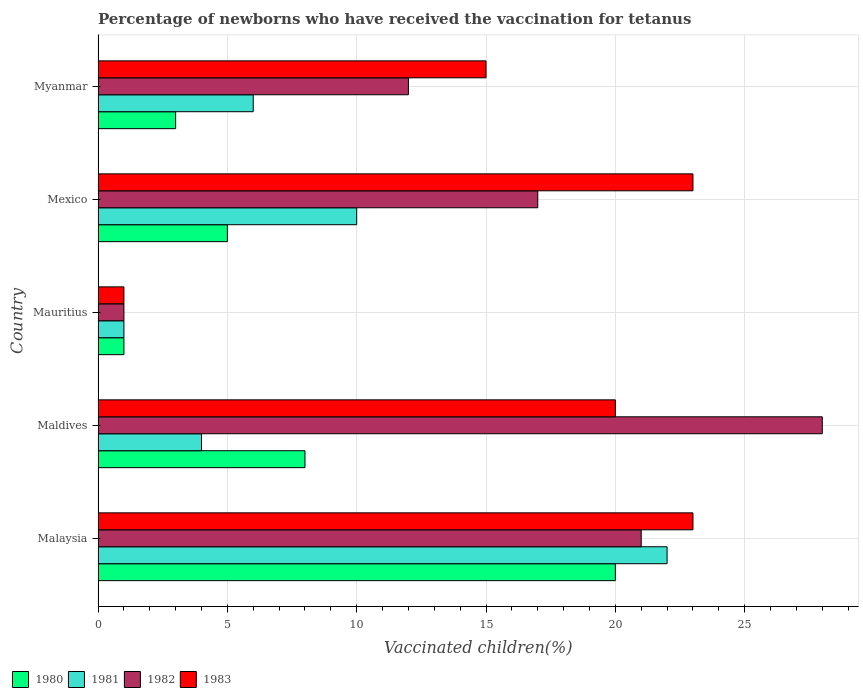How many different coloured bars are there?
Your answer should be very brief. 4. How many groups of bars are there?
Your answer should be compact. 5. Are the number of bars per tick equal to the number of legend labels?
Your response must be concise. Yes. Are the number of bars on each tick of the Y-axis equal?
Provide a short and direct response. Yes. What is the label of the 2nd group of bars from the top?
Provide a succinct answer. Mexico. In how many cases, is the number of bars for a given country not equal to the number of legend labels?
Give a very brief answer. 0. Across all countries, what is the minimum percentage of vaccinated children in 1982?
Your response must be concise. 1. In which country was the percentage of vaccinated children in 1983 maximum?
Make the answer very short. Malaysia. In which country was the percentage of vaccinated children in 1983 minimum?
Ensure brevity in your answer.  Mauritius. What is the total percentage of vaccinated children in 1983 in the graph?
Your response must be concise. 82. What is the difference between the percentage of vaccinated children in 1983 in Maldives and the percentage of vaccinated children in 1980 in Mauritius?
Your response must be concise. 19. What is the average percentage of vaccinated children in 1983 per country?
Offer a terse response. 16.4. In how many countries, is the percentage of vaccinated children in 1981 greater than 28 %?
Provide a short and direct response. 0. What is the ratio of the percentage of vaccinated children in 1983 in Maldives to that in Myanmar?
Keep it short and to the point. 1.33. Is the difference between the percentage of vaccinated children in 1980 in Maldives and Mauritius greater than the difference between the percentage of vaccinated children in 1983 in Maldives and Mauritius?
Ensure brevity in your answer.  No. In how many countries, is the percentage of vaccinated children in 1983 greater than the average percentage of vaccinated children in 1983 taken over all countries?
Your answer should be very brief. 3. Is it the case that in every country, the sum of the percentage of vaccinated children in 1983 and percentage of vaccinated children in 1981 is greater than the sum of percentage of vaccinated children in 1982 and percentage of vaccinated children in 1980?
Provide a short and direct response. No. What does the 4th bar from the top in Maldives represents?
Your answer should be very brief. 1980. Is it the case that in every country, the sum of the percentage of vaccinated children in 1981 and percentage of vaccinated children in 1982 is greater than the percentage of vaccinated children in 1980?
Your response must be concise. Yes. How many bars are there?
Provide a succinct answer. 20. Are all the bars in the graph horizontal?
Provide a short and direct response. Yes. How many countries are there in the graph?
Your answer should be very brief. 5. Are the values on the major ticks of X-axis written in scientific E-notation?
Your answer should be very brief. No. Does the graph contain grids?
Ensure brevity in your answer.  Yes. Where does the legend appear in the graph?
Offer a terse response. Bottom left. How many legend labels are there?
Offer a very short reply. 4. How are the legend labels stacked?
Keep it short and to the point. Horizontal. What is the title of the graph?
Your answer should be compact. Percentage of newborns who have received the vaccination for tetanus. What is the label or title of the X-axis?
Offer a very short reply. Vaccinated children(%). What is the label or title of the Y-axis?
Make the answer very short. Country. What is the Vaccinated children(%) of 1980 in Malaysia?
Offer a very short reply. 20. What is the Vaccinated children(%) in 1981 in Malaysia?
Provide a short and direct response. 22. What is the Vaccinated children(%) in 1982 in Malaysia?
Ensure brevity in your answer.  21. What is the Vaccinated children(%) in 1983 in Malaysia?
Make the answer very short. 23. What is the Vaccinated children(%) in 1981 in Maldives?
Provide a short and direct response. 4. What is the Vaccinated children(%) in 1982 in Maldives?
Offer a terse response. 28. What is the Vaccinated children(%) of 1983 in Maldives?
Give a very brief answer. 20. What is the Vaccinated children(%) of 1981 in Mauritius?
Keep it short and to the point. 1. What is the Vaccinated children(%) in 1982 in Mauritius?
Provide a succinct answer. 1. What is the Vaccinated children(%) in 1983 in Mauritius?
Offer a terse response. 1. What is the Vaccinated children(%) of 1982 in Mexico?
Keep it short and to the point. 17. What is the Vaccinated children(%) in 1983 in Mexico?
Your answer should be very brief. 23. What is the Vaccinated children(%) of 1980 in Myanmar?
Your response must be concise. 3. What is the Vaccinated children(%) of 1981 in Myanmar?
Make the answer very short. 6. What is the Vaccinated children(%) in 1983 in Myanmar?
Make the answer very short. 15. Across all countries, what is the maximum Vaccinated children(%) of 1980?
Provide a short and direct response. 20. Across all countries, what is the maximum Vaccinated children(%) in 1983?
Offer a very short reply. 23. Across all countries, what is the minimum Vaccinated children(%) in 1981?
Offer a terse response. 1. Across all countries, what is the minimum Vaccinated children(%) in 1982?
Provide a short and direct response. 1. What is the total Vaccinated children(%) in 1980 in the graph?
Give a very brief answer. 37. What is the total Vaccinated children(%) of 1982 in the graph?
Your response must be concise. 79. What is the difference between the Vaccinated children(%) of 1980 in Malaysia and that in Maldives?
Give a very brief answer. 12. What is the difference between the Vaccinated children(%) in 1981 in Malaysia and that in Maldives?
Offer a very short reply. 18. What is the difference between the Vaccinated children(%) of 1983 in Malaysia and that in Maldives?
Ensure brevity in your answer.  3. What is the difference between the Vaccinated children(%) in 1980 in Malaysia and that in Mauritius?
Offer a terse response. 19. What is the difference between the Vaccinated children(%) of 1981 in Malaysia and that in Mauritius?
Provide a short and direct response. 21. What is the difference between the Vaccinated children(%) in 1982 in Malaysia and that in Mauritius?
Offer a very short reply. 20. What is the difference between the Vaccinated children(%) in 1983 in Malaysia and that in Mauritius?
Ensure brevity in your answer.  22. What is the difference between the Vaccinated children(%) of 1980 in Malaysia and that in Mexico?
Provide a succinct answer. 15. What is the difference between the Vaccinated children(%) in 1981 in Malaysia and that in Mexico?
Ensure brevity in your answer.  12. What is the difference between the Vaccinated children(%) of 1982 in Malaysia and that in Myanmar?
Provide a short and direct response. 9. What is the difference between the Vaccinated children(%) of 1983 in Malaysia and that in Myanmar?
Offer a terse response. 8. What is the difference between the Vaccinated children(%) of 1981 in Maldives and that in Mauritius?
Provide a succinct answer. 3. What is the difference between the Vaccinated children(%) in 1982 in Maldives and that in Mauritius?
Your answer should be compact. 27. What is the difference between the Vaccinated children(%) of 1983 in Maldives and that in Mauritius?
Provide a succinct answer. 19. What is the difference between the Vaccinated children(%) of 1981 in Maldives and that in Mexico?
Keep it short and to the point. -6. What is the difference between the Vaccinated children(%) of 1980 in Maldives and that in Myanmar?
Your answer should be very brief. 5. What is the difference between the Vaccinated children(%) of 1983 in Maldives and that in Myanmar?
Make the answer very short. 5. What is the difference between the Vaccinated children(%) in 1980 in Mauritius and that in Mexico?
Ensure brevity in your answer.  -4. What is the difference between the Vaccinated children(%) of 1981 in Mauritius and that in Mexico?
Your answer should be compact. -9. What is the difference between the Vaccinated children(%) of 1982 in Mauritius and that in Mexico?
Your answer should be compact. -16. What is the difference between the Vaccinated children(%) of 1983 in Mauritius and that in Mexico?
Provide a succinct answer. -22. What is the difference between the Vaccinated children(%) of 1982 in Mauritius and that in Myanmar?
Ensure brevity in your answer.  -11. What is the difference between the Vaccinated children(%) in 1983 in Mauritius and that in Myanmar?
Offer a very short reply. -14. What is the difference between the Vaccinated children(%) of 1980 in Mexico and that in Myanmar?
Give a very brief answer. 2. What is the difference between the Vaccinated children(%) in 1980 in Malaysia and the Vaccinated children(%) in 1981 in Maldives?
Offer a terse response. 16. What is the difference between the Vaccinated children(%) of 1980 in Malaysia and the Vaccinated children(%) of 1982 in Maldives?
Keep it short and to the point. -8. What is the difference between the Vaccinated children(%) in 1981 in Malaysia and the Vaccinated children(%) in 1983 in Maldives?
Provide a short and direct response. 2. What is the difference between the Vaccinated children(%) of 1982 in Malaysia and the Vaccinated children(%) of 1983 in Maldives?
Provide a succinct answer. 1. What is the difference between the Vaccinated children(%) of 1980 in Malaysia and the Vaccinated children(%) of 1983 in Mauritius?
Offer a very short reply. 19. What is the difference between the Vaccinated children(%) of 1981 in Malaysia and the Vaccinated children(%) of 1982 in Mexico?
Offer a very short reply. 5. What is the difference between the Vaccinated children(%) of 1981 in Malaysia and the Vaccinated children(%) of 1983 in Mexico?
Make the answer very short. -1. What is the difference between the Vaccinated children(%) in 1980 in Malaysia and the Vaccinated children(%) in 1981 in Myanmar?
Keep it short and to the point. 14. What is the difference between the Vaccinated children(%) of 1981 in Malaysia and the Vaccinated children(%) of 1983 in Myanmar?
Offer a terse response. 7. What is the difference between the Vaccinated children(%) in 1982 in Malaysia and the Vaccinated children(%) in 1983 in Myanmar?
Your answer should be compact. 6. What is the difference between the Vaccinated children(%) in 1980 in Maldives and the Vaccinated children(%) in 1981 in Mauritius?
Your answer should be compact. 7. What is the difference between the Vaccinated children(%) in 1980 in Maldives and the Vaccinated children(%) in 1983 in Mauritius?
Ensure brevity in your answer.  7. What is the difference between the Vaccinated children(%) in 1981 in Maldives and the Vaccinated children(%) in 1983 in Mauritius?
Make the answer very short. 3. What is the difference between the Vaccinated children(%) of 1980 in Maldives and the Vaccinated children(%) of 1981 in Mexico?
Your answer should be compact. -2. What is the difference between the Vaccinated children(%) of 1980 in Maldives and the Vaccinated children(%) of 1982 in Mexico?
Provide a short and direct response. -9. What is the difference between the Vaccinated children(%) in 1980 in Maldives and the Vaccinated children(%) in 1983 in Mexico?
Ensure brevity in your answer.  -15. What is the difference between the Vaccinated children(%) in 1981 in Maldives and the Vaccinated children(%) in 1983 in Mexico?
Offer a very short reply. -19. What is the difference between the Vaccinated children(%) in 1980 in Maldives and the Vaccinated children(%) in 1982 in Myanmar?
Ensure brevity in your answer.  -4. What is the difference between the Vaccinated children(%) in 1980 in Maldives and the Vaccinated children(%) in 1983 in Myanmar?
Provide a succinct answer. -7. What is the difference between the Vaccinated children(%) of 1981 in Maldives and the Vaccinated children(%) of 1982 in Myanmar?
Provide a succinct answer. -8. What is the difference between the Vaccinated children(%) in 1982 in Maldives and the Vaccinated children(%) in 1983 in Myanmar?
Provide a succinct answer. 13. What is the difference between the Vaccinated children(%) of 1980 in Mauritius and the Vaccinated children(%) of 1982 in Mexico?
Ensure brevity in your answer.  -16. What is the difference between the Vaccinated children(%) in 1981 in Mauritius and the Vaccinated children(%) in 1983 in Mexico?
Your response must be concise. -22. What is the difference between the Vaccinated children(%) in 1982 in Mauritius and the Vaccinated children(%) in 1983 in Mexico?
Provide a succinct answer. -22. What is the difference between the Vaccinated children(%) in 1980 in Mauritius and the Vaccinated children(%) in 1983 in Myanmar?
Make the answer very short. -14. What is the difference between the Vaccinated children(%) of 1981 in Mauritius and the Vaccinated children(%) of 1983 in Myanmar?
Provide a short and direct response. -14. What is the difference between the Vaccinated children(%) of 1980 in Mexico and the Vaccinated children(%) of 1983 in Myanmar?
Provide a succinct answer. -10. What is the average Vaccinated children(%) of 1980 per country?
Give a very brief answer. 7.4. What is the average Vaccinated children(%) of 1982 per country?
Provide a succinct answer. 15.8. What is the average Vaccinated children(%) of 1983 per country?
Give a very brief answer. 16.4. What is the difference between the Vaccinated children(%) in 1980 and Vaccinated children(%) in 1981 in Malaysia?
Keep it short and to the point. -2. What is the difference between the Vaccinated children(%) of 1980 and Vaccinated children(%) of 1982 in Malaysia?
Offer a terse response. -1. What is the difference between the Vaccinated children(%) in 1980 and Vaccinated children(%) in 1983 in Malaysia?
Keep it short and to the point. -3. What is the difference between the Vaccinated children(%) of 1981 and Vaccinated children(%) of 1983 in Malaysia?
Your answer should be compact. -1. What is the difference between the Vaccinated children(%) of 1980 and Vaccinated children(%) of 1981 in Mauritius?
Your answer should be very brief. 0. What is the difference between the Vaccinated children(%) of 1981 and Vaccinated children(%) of 1982 in Mauritius?
Provide a succinct answer. 0. What is the difference between the Vaccinated children(%) of 1980 and Vaccinated children(%) of 1981 in Mexico?
Provide a short and direct response. -5. What is the difference between the Vaccinated children(%) in 1981 and Vaccinated children(%) in 1982 in Mexico?
Your answer should be compact. -7. What is the difference between the Vaccinated children(%) of 1981 and Vaccinated children(%) of 1983 in Mexico?
Give a very brief answer. -13. What is the difference between the Vaccinated children(%) in 1982 and Vaccinated children(%) in 1983 in Mexico?
Provide a succinct answer. -6. What is the difference between the Vaccinated children(%) in 1980 and Vaccinated children(%) in 1981 in Myanmar?
Offer a very short reply. -3. What is the difference between the Vaccinated children(%) in 1981 and Vaccinated children(%) in 1982 in Myanmar?
Your answer should be compact. -6. What is the difference between the Vaccinated children(%) of 1981 and Vaccinated children(%) of 1983 in Myanmar?
Ensure brevity in your answer.  -9. What is the difference between the Vaccinated children(%) of 1982 and Vaccinated children(%) of 1983 in Myanmar?
Make the answer very short. -3. What is the ratio of the Vaccinated children(%) of 1981 in Malaysia to that in Maldives?
Your answer should be compact. 5.5. What is the ratio of the Vaccinated children(%) in 1982 in Malaysia to that in Maldives?
Your answer should be very brief. 0.75. What is the ratio of the Vaccinated children(%) in 1983 in Malaysia to that in Maldives?
Provide a short and direct response. 1.15. What is the ratio of the Vaccinated children(%) of 1980 in Malaysia to that in Mauritius?
Keep it short and to the point. 20. What is the ratio of the Vaccinated children(%) of 1981 in Malaysia to that in Mauritius?
Offer a terse response. 22. What is the ratio of the Vaccinated children(%) in 1981 in Malaysia to that in Mexico?
Offer a terse response. 2.2. What is the ratio of the Vaccinated children(%) in 1982 in Malaysia to that in Mexico?
Offer a terse response. 1.24. What is the ratio of the Vaccinated children(%) in 1983 in Malaysia to that in Mexico?
Make the answer very short. 1. What is the ratio of the Vaccinated children(%) of 1980 in Malaysia to that in Myanmar?
Give a very brief answer. 6.67. What is the ratio of the Vaccinated children(%) of 1981 in Malaysia to that in Myanmar?
Your answer should be very brief. 3.67. What is the ratio of the Vaccinated children(%) of 1982 in Malaysia to that in Myanmar?
Give a very brief answer. 1.75. What is the ratio of the Vaccinated children(%) in 1983 in Malaysia to that in Myanmar?
Provide a short and direct response. 1.53. What is the ratio of the Vaccinated children(%) in 1980 in Maldives to that in Mauritius?
Offer a very short reply. 8. What is the ratio of the Vaccinated children(%) of 1980 in Maldives to that in Mexico?
Your answer should be very brief. 1.6. What is the ratio of the Vaccinated children(%) of 1981 in Maldives to that in Mexico?
Make the answer very short. 0.4. What is the ratio of the Vaccinated children(%) in 1982 in Maldives to that in Mexico?
Your answer should be compact. 1.65. What is the ratio of the Vaccinated children(%) of 1983 in Maldives to that in Mexico?
Give a very brief answer. 0.87. What is the ratio of the Vaccinated children(%) of 1980 in Maldives to that in Myanmar?
Ensure brevity in your answer.  2.67. What is the ratio of the Vaccinated children(%) in 1982 in Maldives to that in Myanmar?
Your answer should be compact. 2.33. What is the ratio of the Vaccinated children(%) of 1981 in Mauritius to that in Mexico?
Your answer should be very brief. 0.1. What is the ratio of the Vaccinated children(%) of 1982 in Mauritius to that in Mexico?
Provide a short and direct response. 0.06. What is the ratio of the Vaccinated children(%) in 1983 in Mauritius to that in Mexico?
Your answer should be compact. 0.04. What is the ratio of the Vaccinated children(%) of 1981 in Mauritius to that in Myanmar?
Offer a very short reply. 0.17. What is the ratio of the Vaccinated children(%) of 1982 in Mauritius to that in Myanmar?
Make the answer very short. 0.08. What is the ratio of the Vaccinated children(%) of 1983 in Mauritius to that in Myanmar?
Your answer should be very brief. 0.07. What is the ratio of the Vaccinated children(%) in 1982 in Mexico to that in Myanmar?
Give a very brief answer. 1.42. What is the ratio of the Vaccinated children(%) in 1983 in Mexico to that in Myanmar?
Provide a short and direct response. 1.53. What is the difference between the highest and the second highest Vaccinated children(%) of 1981?
Make the answer very short. 12. What is the difference between the highest and the second highest Vaccinated children(%) of 1983?
Your answer should be compact. 0. What is the difference between the highest and the lowest Vaccinated children(%) of 1980?
Your response must be concise. 19. What is the difference between the highest and the lowest Vaccinated children(%) in 1981?
Provide a succinct answer. 21. What is the difference between the highest and the lowest Vaccinated children(%) of 1983?
Offer a terse response. 22. 